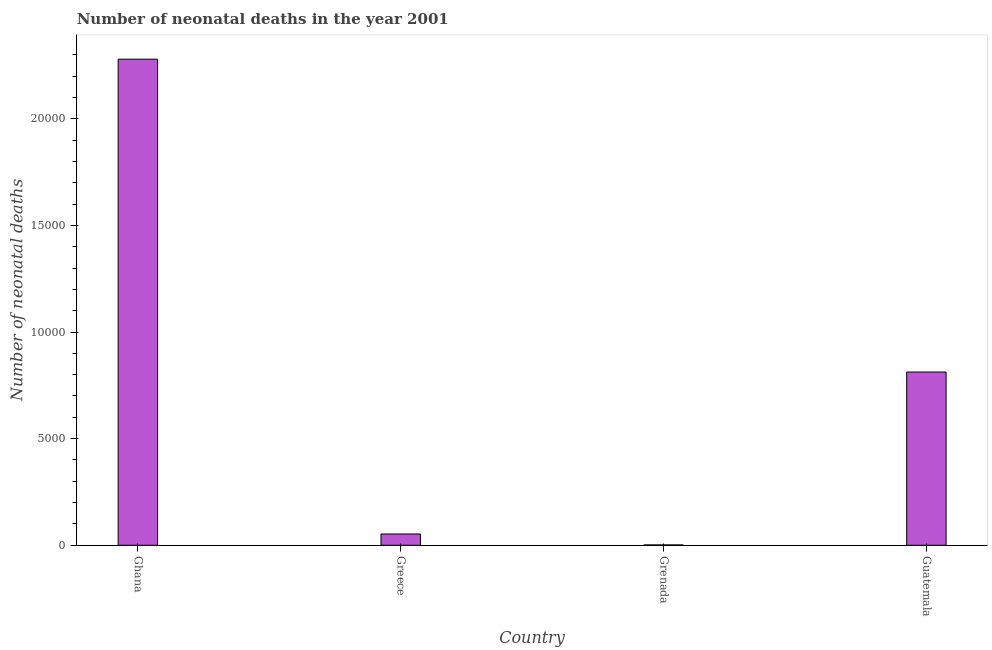Does the graph contain any zero values?
Your answer should be very brief. No. Does the graph contain grids?
Give a very brief answer. No. What is the title of the graph?
Keep it short and to the point. Number of neonatal deaths in the year 2001. What is the label or title of the Y-axis?
Your response must be concise. Number of neonatal deaths. What is the number of neonatal deaths in Guatemala?
Your answer should be very brief. 8124. Across all countries, what is the maximum number of neonatal deaths?
Your answer should be compact. 2.28e+04. Across all countries, what is the minimum number of neonatal deaths?
Give a very brief answer. 16. In which country was the number of neonatal deaths minimum?
Your answer should be very brief. Grenada. What is the sum of the number of neonatal deaths?
Your answer should be very brief. 3.15e+04. What is the difference between the number of neonatal deaths in Grenada and Guatemala?
Keep it short and to the point. -8108. What is the average number of neonatal deaths per country?
Keep it short and to the point. 7866. What is the median number of neonatal deaths?
Provide a short and direct response. 4327. In how many countries, is the number of neonatal deaths greater than 3000 ?
Offer a terse response. 2. What is the ratio of the number of neonatal deaths in Greece to that in Grenada?
Ensure brevity in your answer.  33.12. What is the difference between the highest and the second highest number of neonatal deaths?
Provide a succinct answer. 1.47e+04. What is the difference between the highest and the lowest number of neonatal deaths?
Make the answer very short. 2.28e+04. How many bars are there?
Provide a short and direct response. 4. What is the difference between two consecutive major ticks on the Y-axis?
Your answer should be compact. 5000. What is the Number of neonatal deaths of Ghana?
Your answer should be compact. 2.28e+04. What is the Number of neonatal deaths of Greece?
Your response must be concise. 530. What is the Number of neonatal deaths of Grenada?
Keep it short and to the point. 16. What is the Number of neonatal deaths of Guatemala?
Provide a succinct answer. 8124. What is the difference between the Number of neonatal deaths in Ghana and Greece?
Give a very brief answer. 2.23e+04. What is the difference between the Number of neonatal deaths in Ghana and Grenada?
Provide a succinct answer. 2.28e+04. What is the difference between the Number of neonatal deaths in Ghana and Guatemala?
Offer a terse response. 1.47e+04. What is the difference between the Number of neonatal deaths in Greece and Grenada?
Your response must be concise. 514. What is the difference between the Number of neonatal deaths in Greece and Guatemala?
Give a very brief answer. -7594. What is the difference between the Number of neonatal deaths in Grenada and Guatemala?
Keep it short and to the point. -8108. What is the ratio of the Number of neonatal deaths in Ghana to that in Greece?
Offer a very short reply. 43.01. What is the ratio of the Number of neonatal deaths in Ghana to that in Grenada?
Your response must be concise. 1424.62. What is the ratio of the Number of neonatal deaths in Ghana to that in Guatemala?
Make the answer very short. 2.81. What is the ratio of the Number of neonatal deaths in Greece to that in Grenada?
Make the answer very short. 33.12. What is the ratio of the Number of neonatal deaths in Greece to that in Guatemala?
Offer a very short reply. 0.07. What is the ratio of the Number of neonatal deaths in Grenada to that in Guatemala?
Offer a very short reply. 0. 